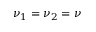Convert formula to latex. <formula><loc_0><loc_0><loc_500><loc_500>\nu _ { 1 } = \nu _ { 2 } = \nu</formula> 